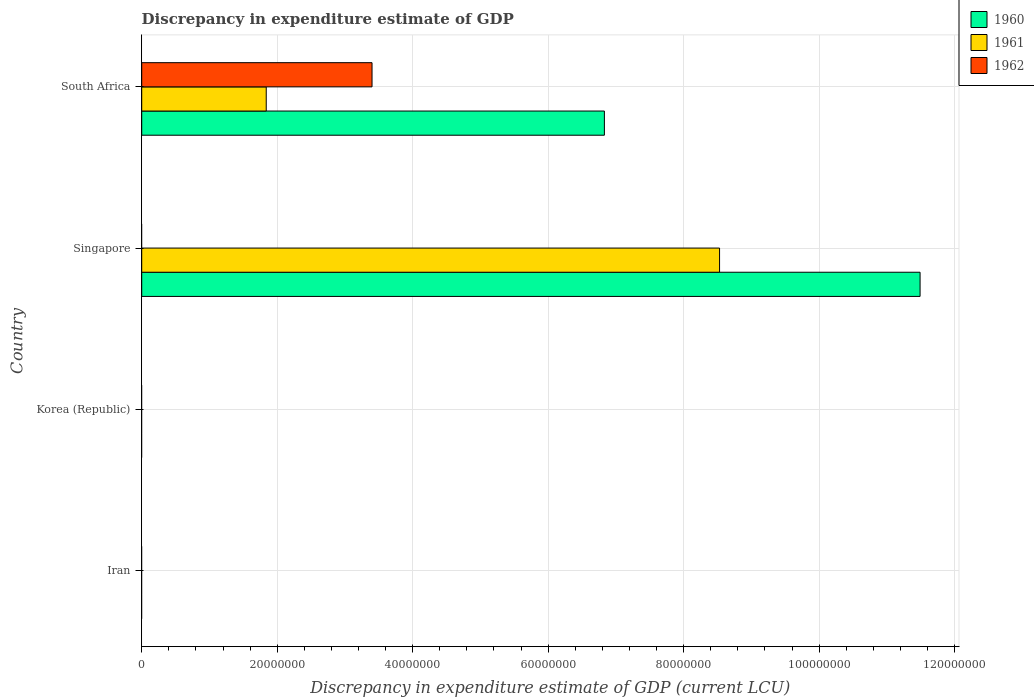How many different coloured bars are there?
Your answer should be very brief. 3. Are the number of bars per tick equal to the number of legend labels?
Give a very brief answer. No. Are the number of bars on each tick of the Y-axis equal?
Give a very brief answer. No. How many bars are there on the 3rd tick from the top?
Keep it short and to the point. 0. What is the label of the 4th group of bars from the top?
Your answer should be compact. Iran. In how many cases, is the number of bars for a given country not equal to the number of legend labels?
Make the answer very short. 3. What is the discrepancy in expenditure estimate of GDP in 1961 in South Africa?
Offer a terse response. 1.84e+07. Across all countries, what is the maximum discrepancy in expenditure estimate of GDP in 1960?
Provide a succinct answer. 1.15e+08. Across all countries, what is the minimum discrepancy in expenditure estimate of GDP in 1960?
Give a very brief answer. 0. In which country was the discrepancy in expenditure estimate of GDP in 1961 maximum?
Ensure brevity in your answer.  Singapore. What is the total discrepancy in expenditure estimate of GDP in 1961 in the graph?
Your answer should be very brief. 1.04e+08. What is the difference between the discrepancy in expenditure estimate of GDP in 1962 in South Africa and the discrepancy in expenditure estimate of GDP in 1961 in Iran?
Give a very brief answer. 3.40e+07. What is the average discrepancy in expenditure estimate of GDP in 1960 per country?
Offer a terse response. 4.58e+07. What is the difference between the discrepancy in expenditure estimate of GDP in 1962 and discrepancy in expenditure estimate of GDP in 1961 in South Africa?
Your response must be concise. 1.56e+07. What is the difference between the highest and the lowest discrepancy in expenditure estimate of GDP in 1961?
Your answer should be compact. 8.53e+07. Is the sum of the discrepancy in expenditure estimate of GDP in 1960 in Singapore and South Africa greater than the maximum discrepancy in expenditure estimate of GDP in 1962 across all countries?
Offer a very short reply. Yes. Is it the case that in every country, the sum of the discrepancy in expenditure estimate of GDP in 1962 and discrepancy in expenditure estimate of GDP in 1961 is greater than the discrepancy in expenditure estimate of GDP in 1960?
Provide a succinct answer. No. Where does the legend appear in the graph?
Make the answer very short. Top right. How are the legend labels stacked?
Give a very brief answer. Vertical. What is the title of the graph?
Offer a terse response. Discrepancy in expenditure estimate of GDP. What is the label or title of the X-axis?
Keep it short and to the point. Discrepancy in expenditure estimate of GDP (current LCU). What is the label or title of the Y-axis?
Provide a succinct answer. Country. What is the Discrepancy in expenditure estimate of GDP (current LCU) of 1960 in Iran?
Give a very brief answer. 0. What is the Discrepancy in expenditure estimate of GDP (current LCU) in 1961 in Iran?
Provide a short and direct response. 0. What is the Discrepancy in expenditure estimate of GDP (current LCU) of 1960 in Korea (Republic)?
Your answer should be very brief. 0. What is the Discrepancy in expenditure estimate of GDP (current LCU) of 1962 in Korea (Republic)?
Give a very brief answer. 0. What is the Discrepancy in expenditure estimate of GDP (current LCU) of 1960 in Singapore?
Keep it short and to the point. 1.15e+08. What is the Discrepancy in expenditure estimate of GDP (current LCU) of 1961 in Singapore?
Keep it short and to the point. 8.53e+07. What is the Discrepancy in expenditure estimate of GDP (current LCU) in 1960 in South Africa?
Offer a terse response. 6.83e+07. What is the Discrepancy in expenditure estimate of GDP (current LCU) of 1961 in South Africa?
Offer a terse response. 1.84e+07. What is the Discrepancy in expenditure estimate of GDP (current LCU) of 1962 in South Africa?
Provide a succinct answer. 3.40e+07. Across all countries, what is the maximum Discrepancy in expenditure estimate of GDP (current LCU) of 1960?
Provide a short and direct response. 1.15e+08. Across all countries, what is the maximum Discrepancy in expenditure estimate of GDP (current LCU) in 1961?
Offer a terse response. 8.53e+07. Across all countries, what is the maximum Discrepancy in expenditure estimate of GDP (current LCU) in 1962?
Keep it short and to the point. 3.40e+07. Across all countries, what is the minimum Discrepancy in expenditure estimate of GDP (current LCU) in 1961?
Make the answer very short. 0. What is the total Discrepancy in expenditure estimate of GDP (current LCU) in 1960 in the graph?
Make the answer very short. 1.83e+08. What is the total Discrepancy in expenditure estimate of GDP (current LCU) in 1961 in the graph?
Offer a very short reply. 1.04e+08. What is the total Discrepancy in expenditure estimate of GDP (current LCU) of 1962 in the graph?
Make the answer very short. 3.40e+07. What is the difference between the Discrepancy in expenditure estimate of GDP (current LCU) of 1960 in Singapore and that in South Africa?
Your response must be concise. 4.66e+07. What is the difference between the Discrepancy in expenditure estimate of GDP (current LCU) of 1961 in Singapore and that in South Africa?
Keep it short and to the point. 6.69e+07. What is the difference between the Discrepancy in expenditure estimate of GDP (current LCU) of 1960 in Singapore and the Discrepancy in expenditure estimate of GDP (current LCU) of 1961 in South Africa?
Provide a short and direct response. 9.65e+07. What is the difference between the Discrepancy in expenditure estimate of GDP (current LCU) in 1960 in Singapore and the Discrepancy in expenditure estimate of GDP (current LCU) in 1962 in South Africa?
Provide a succinct answer. 8.09e+07. What is the difference between the Discrepancy in expenditure estimate of GDP (current LCU) in 1961 in Singapore and the Discrepancy in expenditure estimate of GDP (current LCU) in 1962 in South Africa?
Offer a terse response. 5.13e+07. What is the average Discrepancy in expenditure estimate of GDP (current LCU) in 1960 per country?
Provide a short and direct response. 4.58e+07. What is the average Discrepancy in expenditure estimate of GDP (current LCU) in 1961 per country?
Make the answer very short. 2.59e+07. What is the average Discrepancy in expenditure estimate of GDP (current LCU) of 1962 per country?
Provide a succinct answer. 8.50e+06. What is the difference between the Discrepancy in expenditure estimate of GDP (current LCU) in 1960 and Discrepancy in expenditure estimate of GDP (current LCU) in 1961 in Singapore?
Provide a succinct answer. 2.96e+07. What is the difference between the Discrepancy in expenditure estimate of GDP (current LCU) in 1960 and Discrepancy in expenditure estimate of GDP (current LCU) in 1961 in South Africa?
Ensure brevity in your answer.  4.99e+07. What is the difference between the Discrepancy in expenditure estimate of GDP (current LCU) in 1960 and Discrepancy in expenditure estimate of GDP (current LCU) in 1962 in South Africa?
Offer a very short reply. 3.43e+07. What is the difference between the Discrepancy in expenditure estimate of GDP (current LCU) in 1961 and Discrepancy in expenditure estimate of GDP (current LCU) in 1962 in South Africa?
Provide a succinct answer. -1.56e+07. What is the ratio of the Discrepancy in expenditure estimate of GDP (current LCU) in 1960 in Singapore to that in South Africa?
Ensure brevity in your answer.  1.68. What is the ratio of the Discrepancy in expenditure estimate of GDP (current LCU) of 1961 in Singapore to that in South Africa?
Offer a terse response. 4.64. What is the difference between the highest and the lowest Discrepancy in expenditure estimate of GDP (current LCU) of 1960?
Your answer should be very brief. 1.15e+08. What is the difference between the highest and the lowest Discrepancy in expenditure estimate of GDP (current LCU) of 1961?
Your answer should be compact. 8.53e+07. What is the difference between the highest and the lowest Discrepancy in expenditure estimate of GDP (current LCU) in 1962?
Your answer should be very brief. 3.40e+07. 